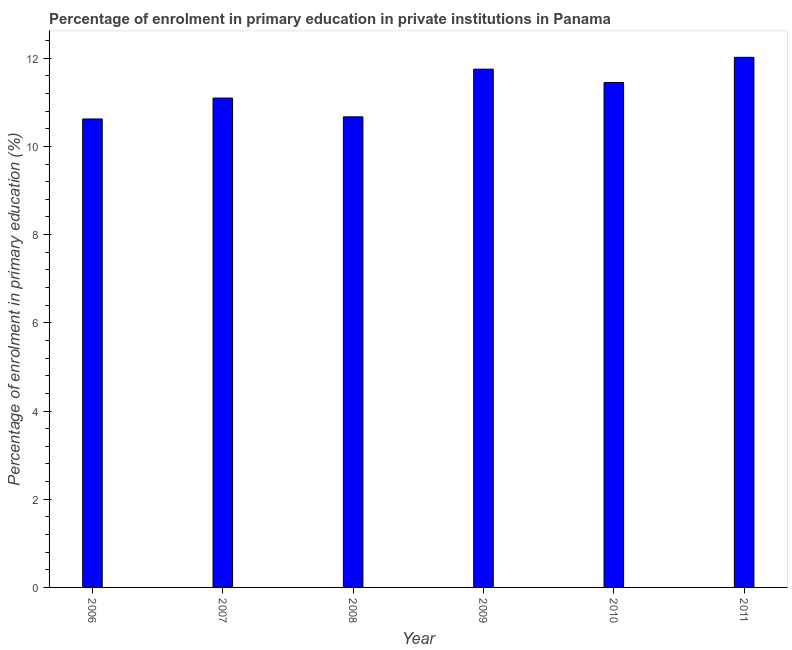Does the graph contain any zero values?
Your answer should be very brief. No. What is the title of the graph?
Your response must be concise. Percentage of enrolment in primary education in private institutions in Panama. What is the label or title of the X-axis?
Provide a short and direct response. Year. What is the label or title of the Y-axis?
Offer a terse response. Percentage of enrolment in primary education (%). What is the enrolment percentage in primary education in 2010?
Your answer should be compact. 11.45. Across all years, what is the maximum enrolment percentage in primary education?
Give a very brief answer. 12.02. Across all years, what is the minimum enrolment percentage in primary education?
Provide a succinct answer. 10.62. In which year was the enrolment percentage in primary education maximum?
Keep it short and to the point. 2011. In which year was the enrolment percentage in primary education minimum?
Offer a terse response. 2006. What is the sum of the enrolment percentage in primary education?
Make the answer very short. 67.61. What is the difference between the enrolment percentage in primary education in 2007 and 2009?
Provide a succinct answer. -0.66. What is the average enrolment percentage in primary education per year?
Ensure brevity in your answer.  11.27. What is the median enrolment percentage in primary education?
Provide a succinct answer. 11.27. In how many years, is the enrolment percentage in primary education greater than 1.6 %?
Offer a terse response. 6. What is the ratio of the enrolment percentage in primary education in 2009 to that in 2011?
Offer a terse response. 0.98. What is the difference between the highest and the second highest enrolment percentage in primary education?
Provide a short and direct response. 0.27. What is the difference between two consecutive major ticks on the Y-axis?
Make the answer very short. 2. Are the values on the major ticks of Y-axis written in scientific E-notation?
Make the answer very short. No. What is the Percentage of enrolment in primary education (%) in 2006?
Offer a terse response. 10.62. What is the Percentage of enrolment in primary education (%) of 2007?
Your answer should be compact. 11.1. What is the Percentage of enrolment in primary education (%) of 2008?
Your answer should be very brief. 10.67. What is the Percentage of enrolment in primary education (%) in 2009?
Make the answer very short. 11.75. What is the Percentage of enrolment in primary education (%) in 2010?
Offer a very short reply. 11.45. What is the Percentage of enrolment in primary education (%) in 2011?
Your response must be concise. 12.02. What is the difference between the Percentage of enrolment in primary education (%) in 2006 and 2007?
Ensure brevity in your answer.  -0.47. What is the difference between the Percentage of enrolment in primary education (%) in 2006 and 2008?
Your answer should be compact. -0.05. What is the difference between the Percentage of enrolment in primary education (%) in 2006 and 2009?
Keep it short and to the point. -1.13. What is the difference between the Percentage of enrolment in primary education (%) in 2006 and 2010?
Give a very brief answer. -0.83. What is the difference between the Percentage of enrolment in primary education (%) in 2006 and 2011?
Your response must be concise. -1.4. What is the difference between the Percentage of enrolment in primary education (%) in 2007 and 2008?
Ensure brevity in your answer.  0.43. What is the difference between the Percentage of enrolment in primary education (%) in 2007 and 2009?
Give a very brief answer. -0.66. What is the difference between the Percentage of enrolment in primary education (%) in 2007 and 2010?
Make the answer very short. -0.35. What is the difference between the Percentage of enrolment in primary education (%) in 2007 and 2011?
Your answer should be compact. -0.92. What is the difference between the Percentage of enrolment in primary education (%) in 2008 and 2009?
Offer a very short reply. -1.08. What is the difference between the Percentage of enrolment in primary education (%) in 2008 and 2010?
Ensure brevity in your answer.  -0.78. What is the difference between the Percentage of enrolment in primary education (%) in 2008 and 2011?
Provide a short and direct response. -1.35. What is the difference between the Percentage of enrolment in primary education (%) in 2009 and 2010?
Make the answer very short. 0.3. What is the difference between the Percentage of enrolment in primary education (%) in 2009 and 2011?
Your answer should be compact. -0.27. What is the difference between the Percentage of enrolment in primary education (%) in 2010 and 2011?
Keep it short and to the point. -0.57. What is the ratio of the Percentage of enrolment in primary education (%) in 2006 to that in 2007?
Offer a terse response. 0.96. What is the ratio of the Percentage of enrolment in primary education (%) in 2006 to that in 2008?
Provide a short and direct response. 0.99. What is the ratio of the Percentage of enrolment in primary education (%) in 2006 to that in 2009?
Provide a succinct answer. 0.9. What is the ratio of the Percentage of enrolment in primary education (%) in 2006 to that in 2010?
Make the answer very short. 0.93. What is the ratio of the Percentage of enrolment in primary education (%) in 2006 to that in 2011?
Offer a very short reply. 0.88. What is the ratio of the Percentage of enrolment in primary education (%) in 2007 to that in 2009?
Provide a succinct answer. 0.94. What is the ratio of the Percentage of enrolment in primary education (%) in 2007 to that in 2010?
Offer a very short reply. 0.97. What is the ratio of the Percentage of enrolment in primary education (%) in 2007 to that in 2011?
Make the answer very short. 0.92. What is the ratio of the Percentage of enrolment in primary education (%) in 2008 to that in 2009?
Ensure brevity in your answer.  0.91. What is the ratio of the Percentage of enrolment in primary education (%) in 2008 to that in 2010?
Ensure brevity in your answer.  0.93. What is the ratio of the Percentage of enrolment in primary education (%) in 2008 to that in 2011?
Your answer should be very brief. 0.89. What is the ratio of the Percentage of enrolment in primary education (%) in 2009 to that in 2010?
Your answer should be compact. 1.03. What is the ratio of the Percentage of enrolment in primary education (%) in 2010 to that in 2011?
Your answer should be very brief. 0.95. 